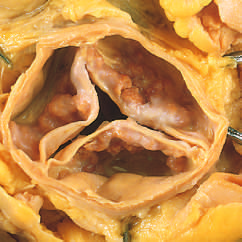re nodular masses of calcium heaped up within the sinuses of valsalva?
Answer the question using a single word or phrase. Yes 